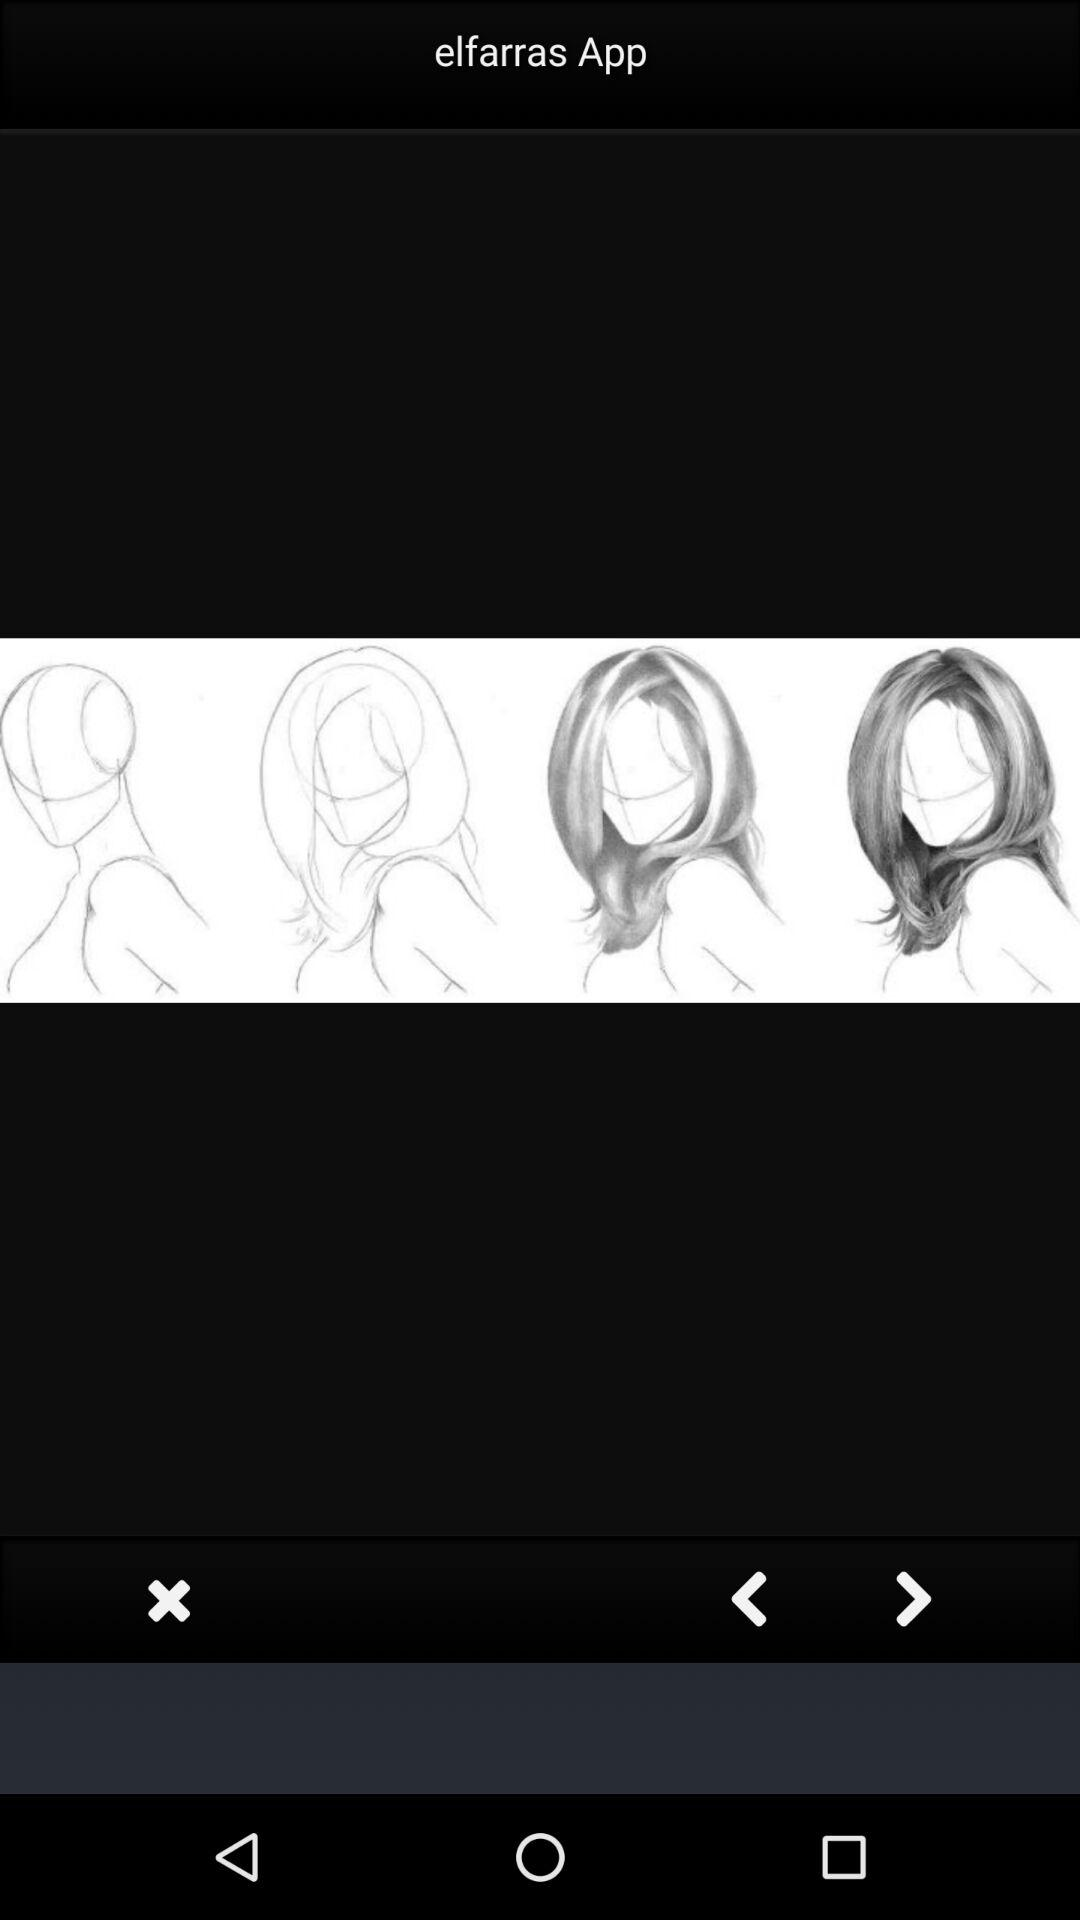What is the name of the app? The name of the app is "elfarras". 